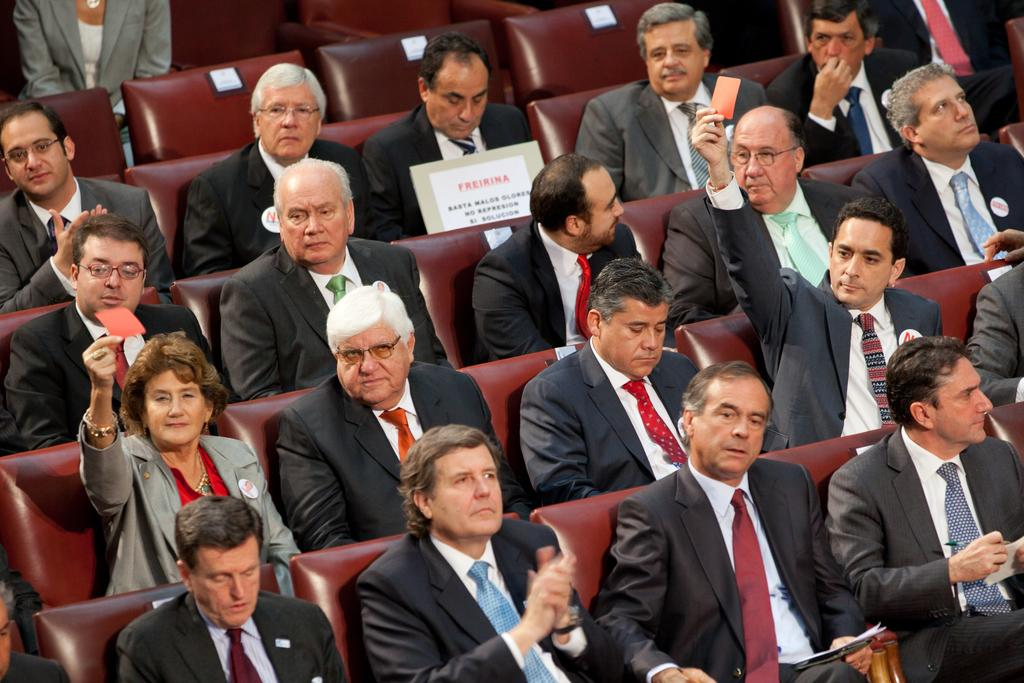What are the people in the image doing? The people in the image are sitting on chairs. What are some of the people holding in their hands? Some people are holding an orange paper slip in their hand. What is the current temperature in the image? The provided facts do not mention the temperature, so it cannot be determined from the image. 